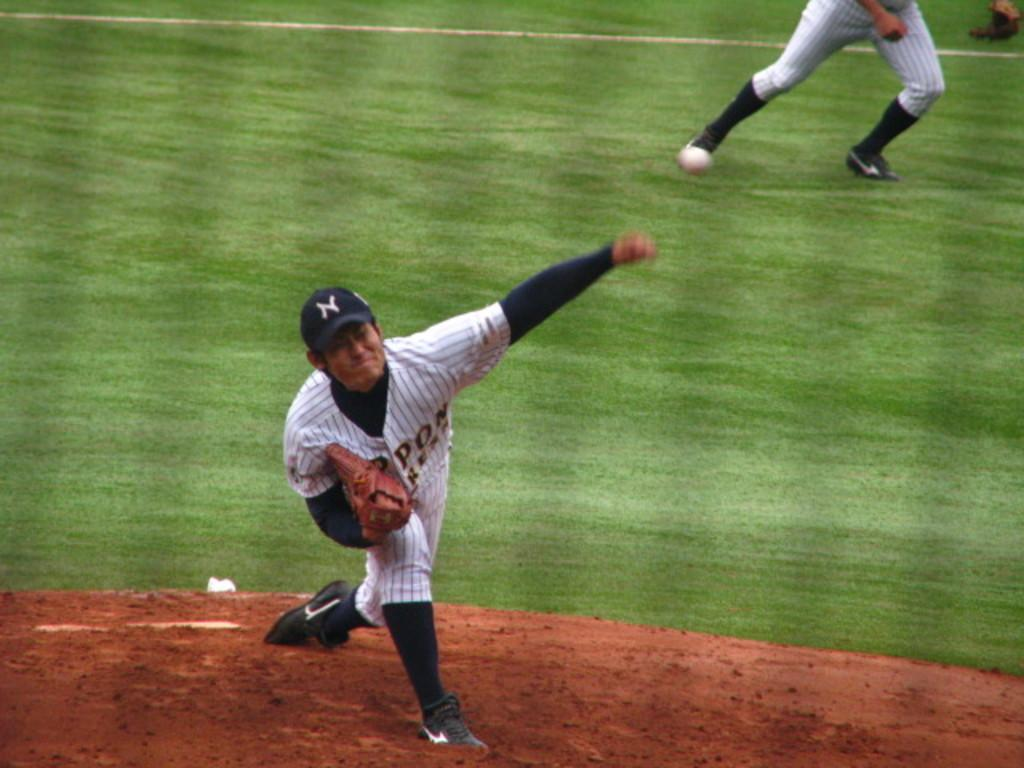How many people are in the image? There are two people in the image. What is the position of the people in the image? The people are on the ground. What type of environment can be seen in the background of the image? There is grass visible in the background of the image. What type of payment is being exchanged between the two people in the image? There is no indication of any payment being exchanged between the two people in the image. 